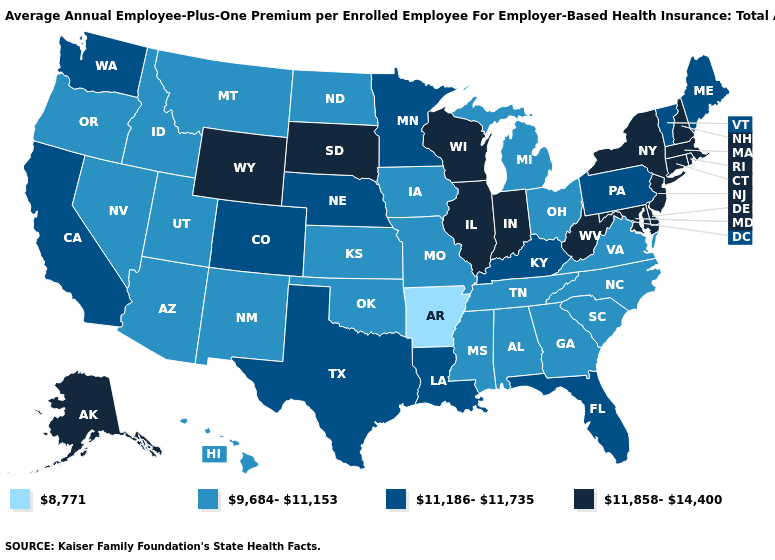Does Missouri have the lowest value in the USA?
Quick response, please. No. Name the states that have a value in the range 8,771?
Write a very short answer. Arkansas. What is the value of Colorado?
Concise answer only. 11,186-11,735. What is the value of Tennessee?
Concise answer only. 9,684-11,153. Which states have the lowest value in the USA?
Quick response, please. Arkansas. Among the states that border Indiana , which have the lowest value?
Give a very brief answer. Michigan, Ohio. Among the states that border Georgia , which have the highest value?
Answer briefly. Florida. Among the states that border New Hampshire , does Massachusetts have the lowest value?
Short answer required. No. Is the legend a continuous bar?
Short answer required. No. What is the value of Utah?
Be succinct. 9,684-11,153. What is the value of Oregon?
Short answer required. 9,684-11,153. Name the states that have a value in the range 8,771?
Short answer required. Arkansas. Among the states that border Wisconsin , which have the lowest value?
Quick response, please. Iowa, Michigan. Does the first symbol in the legend represent the smallest category?
Keep it brief. Yes. Among the states that border Ohio , which have the lowest value?
Short answer required. Michigan. 